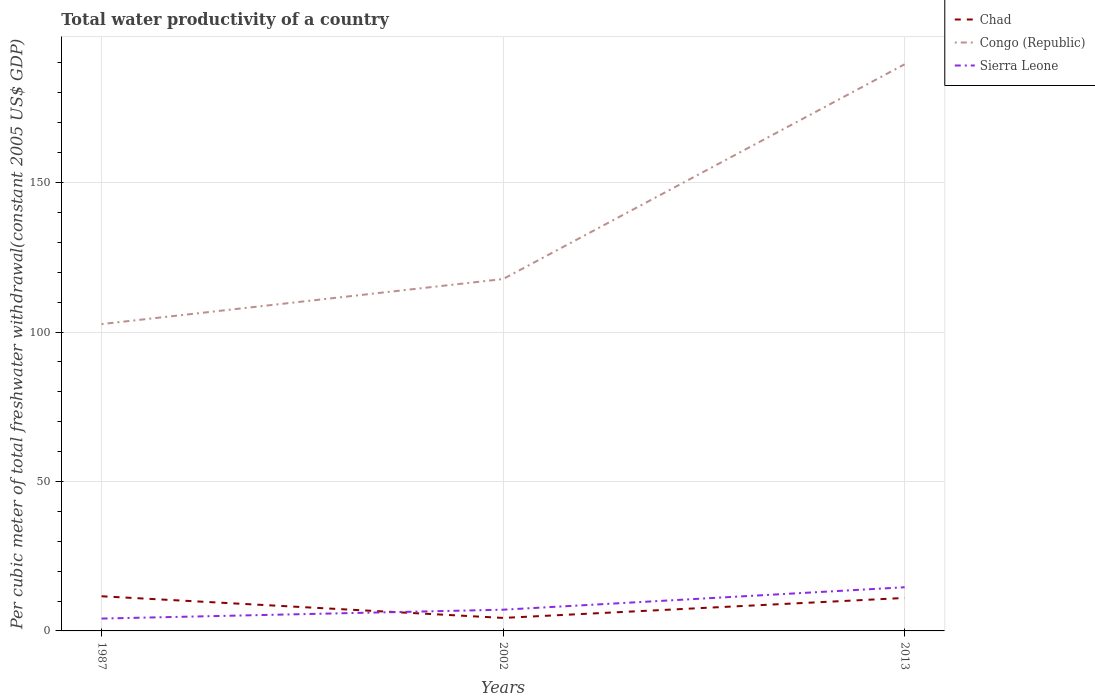How many different coloured lines are there?
Your answer should be compact. 3. Does the line corresponding to Congo (Republic) intersect with the line corresponding to Sierra Leone?
Your response must be concise. No. Is the number of lines equal to the number of legend labels?
Make the answer very short. Yes. Across all years, what is the maximum total water productivity in Sierra Leone?
Provide a succinct answer. 4.13. In which year was the total water productivity in Sierra Leone maximum?
Give a very brief answer. 1987. What is the total total water productivity in Congo (Republic) in the graph?
Provide a short and direct response. -15.07. What is the difference between the highest and the second highest total water productivity in Chad?
Your answer should be very brief. 7.24. How many lines are there?
Offer a terse response. 3. How many years are there in the graph?
Give a very brief answer. 3. How many legend labels are there?
Provide a succinct answer. 3. What is the title of the graph?
Your response must be concise. Total water productivity of a country. Does "South Asia" appear as one of the legend labels in the graph?
Your response must be concise. No. What is the label or title of the X-axis?
Keep it short and to the point. Years. What is the label or title of the Y-axis?
Give a very brief answer. Per cubic meter of total freshwater withdrawal(constant 2005 US$ GDP). What is the Per cubic meter of total freshwater withdrawal(constant 2005 US$ GDP) in Chad in 1987?
Provide a short and direct response. 11.59. What is the Per cubic meter of total freshwater withdrawal(constant 2005 US$ GDP) of Congo (Republic) in 1987?
Give a very brief answer. 102.65. What is the Per cubic meter of total freshwater withdrawal(constant 2005 US$ GDP) in Sierra Leone in 1987?
Provide a short and direct response. 4.13. What is the Per cubic meter of total freshwater withdrawal(constant 2005 US$ GDP) in Chad in 2002?
Provide a short and direct response. 4.35. What is the Per cubic meter of total freshwater withdrawal(constant 2005 US$ GDP) of Congo (Republic) in 2002?
Offer a very short reply. 117.72. What is the Per cubic meter of total freshwater withdrawal(constant 2005 US$ GDP) in Sierra Leone in 2002?
Make the answer very short. 7.1. What is the Per cubic meter of total freshwater withdrawal(constant 2005 US$ GDP) in Chad in 2013?
Provide a short and direct response. 11.03. What is the Per cubic meter of total freshwater withdrawal(constant 2005 US$ GDP) in Congo (Republic) in 2013?
Give a very brief answer. 189.56. What is the Per cubic meter of total freshwater withdrawal(constant 2005 US$ GDP) of Sierra Leone in 2013?
Offer a terse response. 14.61. Across all years, what is the maximum Per cubic meter of total freshwater withdrawal(constant 2005 US$ GDP) in Chad?
Ensure brevity in your answer.  11.59. Across all years, what is the maximum Per cubic meter of total freshwater withdrawal(constant 2005 US$ GDP) in Congo (Republic)?
Your answer should be very brief. 189.56. Across all years, what is the maximum Per cubic meter of total freshwater withdrawal(constant 2005 US$ GDP) in Sierra Leone?
Make the answer very short. 14.61. Across all years, what is the minimum Per cubic meter of total freshwater withdrawal(constant 2005 US$ GDP) of Chad?
Give a very brief answer. 4.35. Across all years, what is the minimum Per cubic meter of total freshwater withdrawal(constant 2005 US$ GDP) in Congo (Republic)?
Your answer should be compact. 102.65. Across all years, what is the minimum Per cubic meter of total freshwater withdrawal(constant 2005 US$ GDP) in Sierra Leone?
Keep it short and to the point. 4.13. What is the total Per cubic meter of total freshwater withdrawal(constant 2005 US$ GDP) of Chad in the graph?
Your answer should be compact. 26.98. What is the total Per cubic meter of total freshwater withdrawal(constant 2005 US$ GDP) of Congo (Republic) in the graph?
Ensure brevity in your answer.  409.93. What is the total Per cubic meter of total freshwater withdrawal(constant 2005 US$ GDP) of Sierra Leone in the graph?
Your answer should be very brief. 25.84. What is the difference between the Per cubic meter of total freshwater withdrawal(constant 2005 US$ GDP) in Chad in 1987 and that in 2002?
Provide a succinct answer. 7.24. What is the difference between the Per cubic meter of total freshwater withdrawal(constant 2005 US$ GDP) of Congo (Republic) in 1987 and that in 2002?
Ensure brevity in your answer.  -15.07. What is the difference between the Per cubic meter of total freshwater withdrawal(constant 2005 US$ GDP) of Sierra Leone in 1987 and that in 2002?
Your answer should be very brief. -2.96. What is the difference between the Per cubic meter of total freshwater withdrawal(constant 2005 US$ GDP) of Chad in 1987 and that in 2013?
Your response must be concise. 0.56. What is the difference between the Per cubic meter of total freshwater withdrawal(constant 2005 US$ GDP) of Congo (Republic) in 1987 and that in 2013?
Your response must be concise. -86.91. What is the difference between the Per cubic meter of total freshwater withdrawal(constant 2005 US$ GDP) in Sierra Leone in 1987 and that in 2013?
Offer a very short reply. -10.47. What is the difference between the Per cubic meter of total freshwater withdrawal(constant 2005 US$ GDP) in Chad in 2002 and that in 2013?
Offer a very short reply. -6.68. What is the difference between the Per cubic meter of total freshwater withdrawal(constant 2005 US$ GDP) in Congo (Republic) in 2002 and that in 2013?
Offer a very short reply. -71.85. What is the difference between the Per cubic meter of total freshwater withdrawal(constant 2005 US$ GDP) in Sierra Leone in 2002 and that in 2013?
Provide a short and direct response. -7.51. What is the difference between the Per cubic meter of total freshwater withdrawal(constant 2005 US$ GDP) in Chad in 1987 and the Per cubic meter of total freshwater withdrawal(constant 2005 US$ GDP) in Congo (Republic) in 2002?
Make the answer very short. -106.13. What is the difference between the Per cubic meter of total freshwater withdrawal(constant 2005 US$ GDP) in Chad in 1987 and the Per cubic meter of total freshwater withdrawal(constant 2005 US$ GDP) in Sierra Leone in 2002?
Your response must be concise. 4.5. What is the difference between the Per cubic meter of total freshwater withdrawal(constant 2005 US$ GDP) of Congo (Republic) in 1987 and the Per cubic meter of total freshwater withdrawal(constant 2005 US$ GDP) of Sierra Leone in 2002?
Ensure brevity in your answer.  95.55. What is the difference between the Per cubic meter of total freshwater withdrawal(constant 2005 US$ GDP) in Chad in 1987 and the Per cubic meter of total freshwater withdrawal(constant 2005 US$ GDP) in Congo (Republic) in 2013?
Give a very brief answer. -177.97. What is the difference between the Per cubic meter of total freshwater withdrawal(constant 2005 US$ GDP) in Chad in 1987 and the Per cubic meter of total freshwater withdrawal(constant 2005 US$ GDP) in Sierra Leone in 2013?
Offer a very short reply. -3.02. What is the difference between the Per cubic meter of total freshwater withdrawal(constant 2005 US$ GDP) of Congo (Republic) in 1987 and the Per cubic meter of total freshwater withdrawal(constant 2005 US$ GDP) of Sierra Leone in 2013?
Make the answer very short. 88.04. What is the difference between the Per cubic meter of total freshwater withdrawal(constant 2005 US$ GDP) in Chad in 2002 and the Per cubic meter of total freshwater withdrawal(constant 2005 US$ GDP) in Congo (Republic) in 2013?
Keep it short and to the point. -185.21. What is the difference between the Per cubic meter of total freshwater withdrawal(constant 2005 US$ GDP) of Chad in 2002 and the Per cubic meter of total freshwater withdrawal(constant 2005 US$ GDP) of Sierra Leone in 2013?
Provide a succinct answer. -10.26. What is the difference between the Per cubic meter of total freshwater withdrawal(constant 2005 US$ GDP) of Congo (Republic) in 2002 and the Per cubic meter of total freshwater withdrawal(constant 2005 US$ GDP) of Sierra Leone in 2013?
Keep it short and to the point. 103.11. What is the average Per cubic meter of total freshwater withdrawal(constant 2005 US$ GDP) in Chad per year?
Give a very brief answer. 8.99. What is the average Per cubic meter of total freshwater withdrawal(constant 2005 US$ GDP) of Congo (Republic) per year?
Give a very brief answer. 136.64. What is the average Per cubic meter of total freshwater withdrawal(constant 2005 US$ GDP) in Sierra Leone per year?
Your answer should be compact. 8.61. In the year 1987, what is the difference between the Per cubic meter of total freshwater withdrawal(constant 2005 US$ GDP) in Chad and Per cubic meter of total freshwater withdrawal(constant 2005 US$ GDP) in Congo (Republic)?
Give a very brief answer. -91.06. In the year 1987, what is the difference between the Per cubic meter of total freshwater withdrawal(constant 2005 US$ GDP) in Chad and Per cubic meter of total freshwater withdrawal(constant 2005 US$ GDP) in Sierra Leone?
Keep it short and to the point. 7.46. In the year 1987, what is the difference between the Per cubic meter of total freshwater withdrawal(constant 2005 US$ GDP) in Congo (Republic) and Per cubic meter of total freshwater withdrawal(constant 2005 US$ GDP) in Sierra Leone?
Ensure brevity in your answer.  98.51. In the year 2002, what is the difference between the Per cubic meter of total freshwater withdrawal(constant 2005 US$ GDP) in Chad and Per cubic meter of total freshwater withdrawal(constant 2005 US$ GDP) in Congo (Republic)?
Provide a succinct answer. -113.37. In the year 2002, what is the difference between the Per cubic meter of total freshwater withdrawal(constant 2005 US$ GDP) in Chad and Per cubic meter of total freshwater withdrawal(constant 2005 US$ GDP) in Sierra Leone?
Make the answer very short. -2.74. In the year 2002, what is the difference between the Per cubic meter of total freshwater withdrawal(constant 2005 US$ GDP) in Congo (Republic) and Per cubic meter of total freshwater withdrawal(constant 2005 US$ GDP) in Sierra Leone?
Offer a terse response. 110.62. In the year 2013, what is the difference between the Per cubic meter of total freshwater withdrawal(constant 2005 US$ GDP) in Chad and Per cubic meter of total freshwater withdrawal(constant 2005 US$ GDP) in Congo (Republic)?
Make the answer very short. -178.53. In the year 2013, what is the difference between the Per cubic meter of total freshwater withdrawal(constant 2005 US$ GDP) in Chad and Per cubic meter of total freshwater withdrawal(constant 2005 US$ GDP) in Sierra Leone?
Provide a short and direct response. -3.57. In the year 2013, what is the difference between the Per cubic meter of total freshwater withdrawal(constant 2005 US$ GDP) in Congo (Republic) and Per cubic meter of total freshwater withdrawal(constant 2005 US$ GDP) in Sierra Leone?
Your answer should be compact. 174.96. What is the ratio of the Per cubic meter of total freshwater withdrawal(constant 2005 US$ GDP) in Chad in 1987 to that in 2002?
Offer a terse response. 2.66. What is the ratio of the Per cubic meter of total freshwater withdrawal(constant 2005 US$ GDP) of Congo (Republic) in 1987 to that in 2002?
Your answer should be compact. 0.87. What is the ratio of the Per cubic meter of total freshwater withdrawal(constant 2005 US$ GDP) in Sierra Leone in 1987 to that in 2002?
Offer a terse response. 0.58. What is the ratio of the Per cubic meter of total freshwater withdrawal(constant 2005 US$ GDP) in Chad in 1987 to that in 2013?
Make the answer very short. 1.05. What is the ratio of the Per cubic meter of total freshwater withdrawal(constant 2005 US$ GDP) of Congo (Republic) in 1987 to that in 2013?
Offer a very short reply. 0.54. What is the ratio of the Per cubic meter of total freshwater withdrawal(constant 2005 US$ GDP) in Sierra Leone in 1987 to that in 2013?
Your answer should be very brief. 0.28. What is the ratio of the Per cubic meter of total freshwater withdrawal(constant 2005 US$ GDP) in Chad in 2002 to that in 2013?
Provide a succinct answer. 0.39. What is the ratio of the Per cubic meter of total freshwater withdrawal(constant 2005 US$ GDP) in Congo (Republic) in 2002 to that in 2013?
Give a very brief answer. 0.62. What is the ratio of the Per cubic meter of total freshwater withdrawal(constant 2005 US$ GDP) in Sierra Leone in 2002 to that in 2013?
Make the answer very short. 0.49. What is the difference between the highest and the second highest Per cubic meter of total freshwater withdrawal(constant 2005 US$ GDP) in Chad?
Offer a very short reply. 0.56. What is the difference between the highest and the second highest Per cubic meter of total freshwater withdrawal(constant 2005 US$ GDP) of Congo (Republic)?
Offer a very short reply. 71.85. What is the difference between the highest and the second highest Per cubic meter of total freshwater withdrawal(constant 2005 US$ GDP) in Sierra Leone?
Provide a succinct answer. 7.51. What is the difference between the highest and the lowest Per cubic meter of total freshwater withdrawal(constant 2005 US$ GDP) in Chad?
Offer a very short reply. 7.24. What is the difference between the highest and the lowest Per cubic meter of total freshwater withdrawal(constant 2005 US$ GDP) in Congo (Republic)?
Offer a very short reply. 86.91. What is the difference between the highest and the lowest Per cubic meter of total freshwater withdrawal(constant 2005 US$ GDP) in Sierra Leone?
Offer a very short reply. 10.47. 